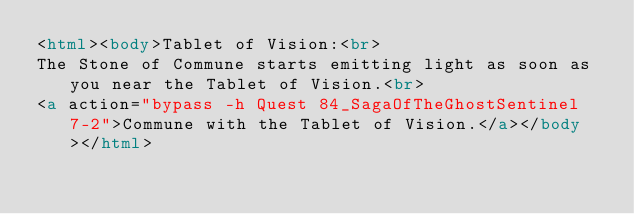Convert code to text. <code><loc_0><loc_0><loc_500><loc_500><_HTML_><html><body>Tablet of Vision:<br>
The Stone of Commune starts emitting light as soon as you near the Tablet of Vision.<br>
<a action="bypass -h Quest 84_SagaOfTheGhostSentinel 7-2">Commune with the Tablet of Vision.</a></body></html></code> 